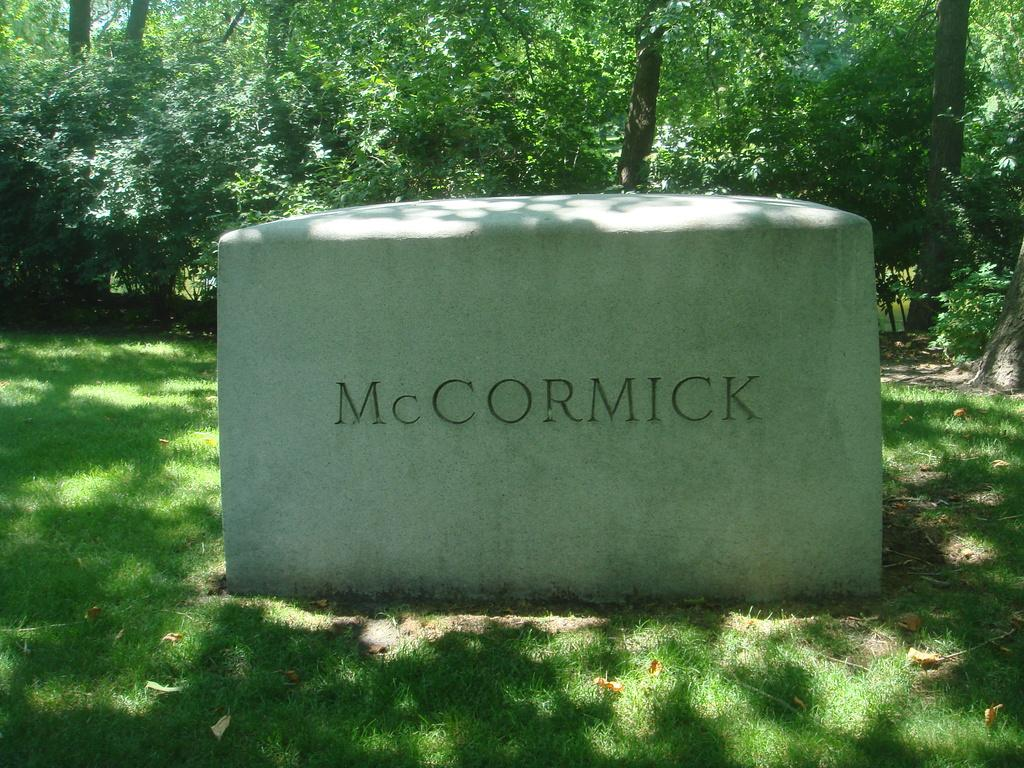What is the main object in the image? There is a stone in the image. Is there any text or writing on the stone? Yes, the stone has something written on it. Where is the stone located? The stone is placed on a greenery ground. What can be seen in the background of the image? There are trees in the background of the image. What type of jam is being spread on the stone in the image? There is no jam or any food item present in the image; it only features a stone with writing on it. 